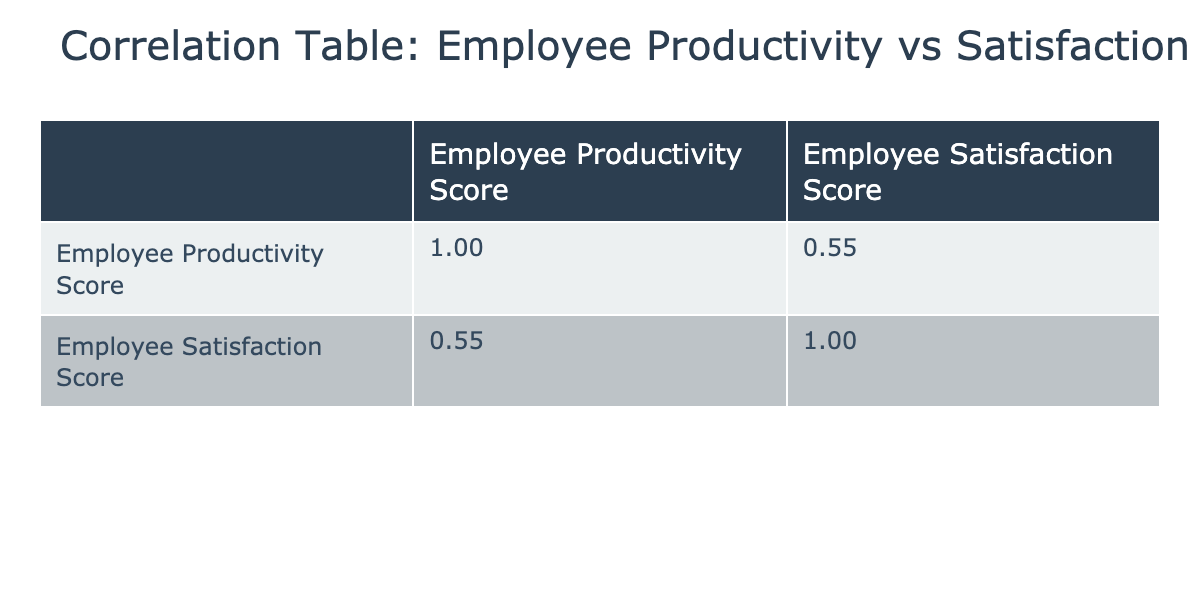What is the correlation coefficient between employee productivity and employee satisfaction? The correlation coefficient is found at the intersection of the respective scores in the correlation table. Here, the correlation coefficient between employee productivity and employee satisfaction is 0.65.
Answer: 0.65 Which department has the highest employee productivity score? By reviewing the employee productivity scores in the table, Engineering has the highest score of 92.
Answer: Engineering What is the average employee satisfaction score for all departments? To find the average, add all employee satisfaction scores (90 + 85 + 82 + 88 + 92 + 80 + 91 + 76 + 89 + 83 + 87 + 79 + 91 + 81 + 85 = 1319) and divide by the number of data points (15). Thus, the average is 1319 / 15 = 87.93.
Answer: 87.93 Is there a positive correlation between employee productivity and employee satisfaction? A positive correlation exists if the correlation coefficient is greater than 0. In this table, since the correlation coefficient is 0.65, we can confirm that there is indeed a positive correlation.
Answer: Yes What is the maximum difference between productivity scores and satisfaction scores for any employee? To find the maximum difference, compute the differences for each employee between their productivity and satisfaction scores and identify the maximum. For example, for employee 3: 92 - 82 = 10. The maximum difference in this instance is 10, which occurs with employee 3.
Answer: 10 Which department has the lowest employee satisfaction score? By checking the satisfaction scores, Human Resources has the lowest score of 76 among all departments.
Answer: Human Resources What is the sum of employee productivity scores for the Marketing department? To find this, add the productivity scores specific to the Marketing department: 78 + 70 + 77 + 75 = 300.
Answer: 300 Are there any employees with a productivity score below 75? Check the productivity scores provided; the scores of employees in the data range from 70 to 92, and since employee 6 has a score of 70, the answer is yes.
Answer: Yes What is the median employee satisfaction score? To find the median, first, arrange the satisfaction scores in ascending order: 76, 79, 80, 81, 82, 83, 85, 87, 88, 89, 90, 91, 91, 92. There are 15 scores, and the 8th score (the median) is 87.
Answer: 87 